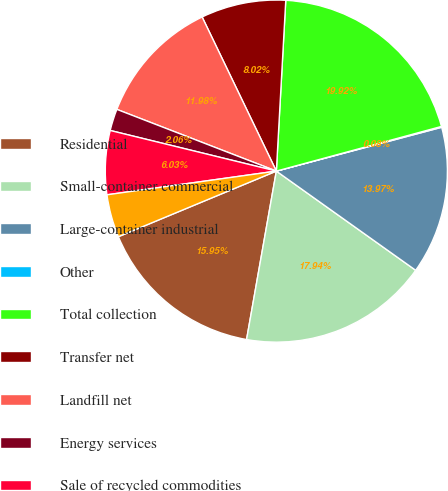<chart> <loc_0><loc_0><loc_500><loc_500><pie_chart><fcel>Residential<fcel>Small-container commercial<fcel>Large-container industrial<fcel>Other<fcel>Total collection<fcel>Transfer net<fcel>Landfill net<fcel>Energy services<fcel>Sale of recycled commodities<fcel>Other non-core<nl><fcel>15.95%<fcel>17.94%<fcel>13.97%<fcel>0.08%<fcel>19.92%<fcel>8.02%<fcel>11.98%<fcel>2.06%<fcel>6.03%<fcel>4.05%<nl></chart> 